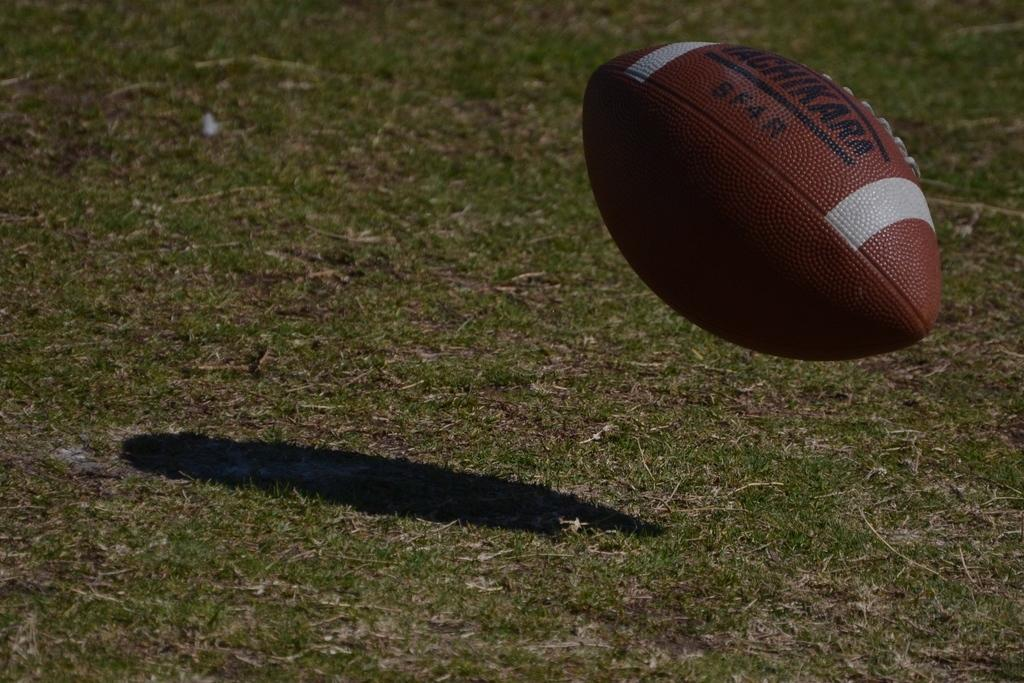What is the main object in the center of the image? There is a ball in the center of the image. What colors can be seen on the ball? The ball is brown and white in color. Is there any text or writing on the ball? Yes, there is writing on the ball. What type of environment is visible in the background of the image? There is grass visible in the background of the image. How many pieces of coal are scattered around the ball in the image? There is no coal present in the image; it only features a ball with writing on it and a grassy background. 